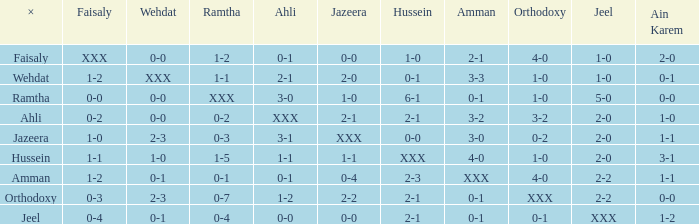If jeel's score is 1-0 and hussein's score is 1-0, what can be said about ramtha? 1-2. 